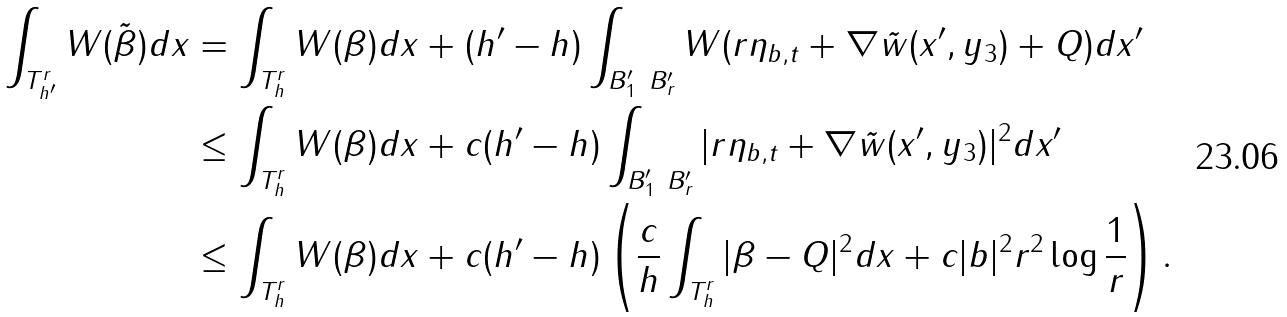<formula> <loc_0><loc_0><loc_500><loc_500>\int _ { T _ { h ^ { \prime } } ^ { r } } W ( \tilde { \beta } ) d x & = \int _ { T _ { h } ^ { r } } W ( \beta ) d x + ( h ^ { \prime } - h ) \int _ { B ^ { \prime } _ { 1 } \ B ^ { \prime } _ { r } } W ( r \eta _ { b , t } + \nabla \tilde { w } ( x ^ { \prime } , y _ { 3 } ) + Q ) d x ^ { \prime } \\ & \leq \int _ { T _ { h } ^ { r } } W ( \beta ) d x + c ( h ^ { \prime } - h ) \int _ { B ^ { \prime } _ { 1 } \ B ^ { \prime } _ { r } } | r \eta _ { b , t } + \nabla \tilde { w } ( x ^ { \prime } , y _ { 3 } ) | ^ { 2 } d x ^ { \prime } \\ & \leq \int _ { T _ { h } ^ { r } } W ( \beta ) d x + c ( h ^ { \prime } - h ) \left ( \frac { c } { h } \int _ { T _ { h } ^ { r } } | \beta - Q | ^ { 2 } d x + c | b | ^ { 2 } r ^ { 2 } \log \frac { 1 } { r } \right ) .</formula> 